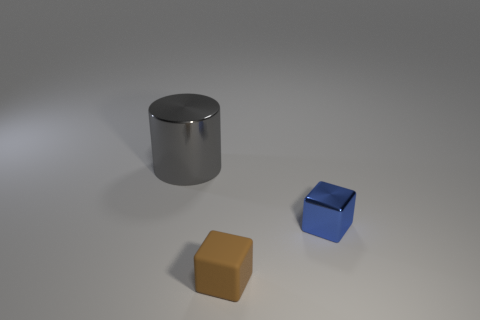Add 1 blue metallic blocks. How many objects exist? 4 Subtract all cubes. How many objects are left? 1 Subtract all tiny matte objects. Subtract all tiny brown objects. How many objects are left? 1 Add 3 blue metallic cubes. How many blue metallic cubes are left? 4 Add 1 tiny matte things. How many tiny matte things exist? 2 Subtract 0 cyan balls. How many objects are left? 3 